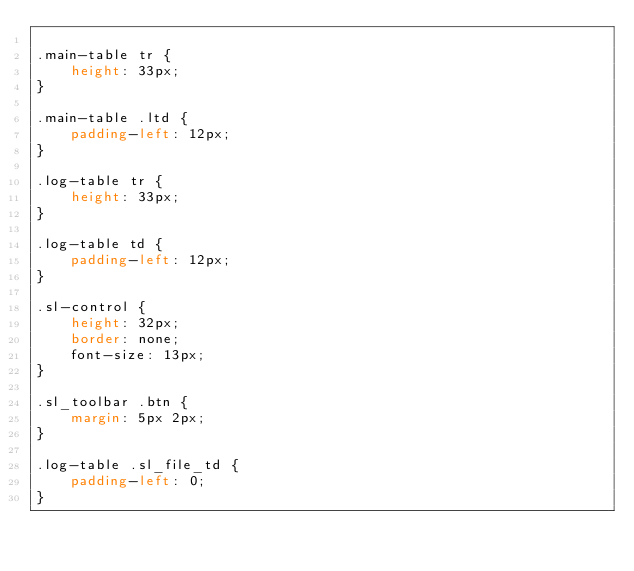Convert code to text. <code><loc_0><loc_0><loc_500><loc_500><_CSS_>
.main-table tr {
    height: 33px;
}

.main-table .ltd {
    padding-left: 12px;
}

.log-table tr {
    height: 33px;
}

.log-table td {
    padding-left: 12px;
}

.sl-control {
    height: 32px;
    border: none;
    font-size: 13px;
}

.sl_toolbar .btn {
    margin: 5px 2px;
}

.log-table .sl_file_td {
    padding-left: 0;
}
</code> 